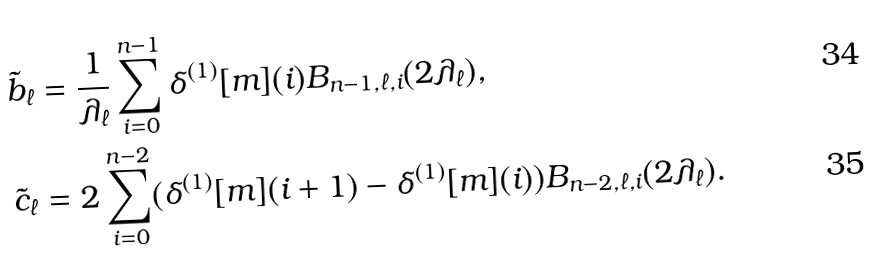Convert formula to latex. <formula><loc_0><loc_0><loc_500><loc_500>\tilde { b } _ { \ell } & = \frac { 1 } { \lambda _ { \ell } } \sum _ { i = 0 } ^ { n - 1 } \delta ^ { ( 1 ) } [ m ] ( i ) B _ { n - 1 , \ell , i } ( 2 \lambda _ { \ell } ) , \\ \tilde { c } _ { \ell } & = 2 \sum _ { i = 0 } ^ { n - 2 } ( \delta ^ { ( 1 ) } [ m ] ( i + 1 ) - \delta ^ { ( 1 ) } [ m ] ( i ) ) B _ { n - 2 , \ell , i } ( 2 \lambda _ { \ell } ) .</formula> 